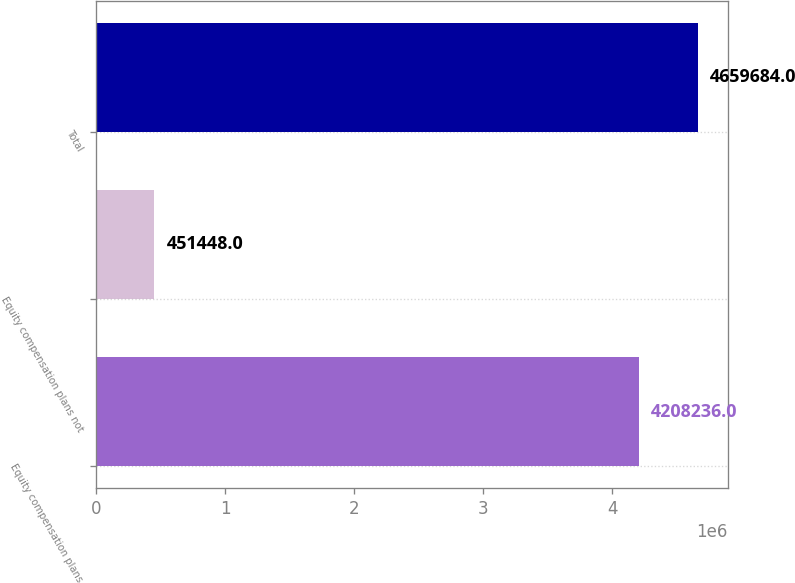<chart> <loc_0><loc_0><loc_500><loc_500><bar_chart><fcel>Equity compensation plans<fcel>Equity compensation plans not<fcel>Total<nl><fcel>4.20824e+06<fcel>451448<fcel>4.65968e+06<nl></chart> 